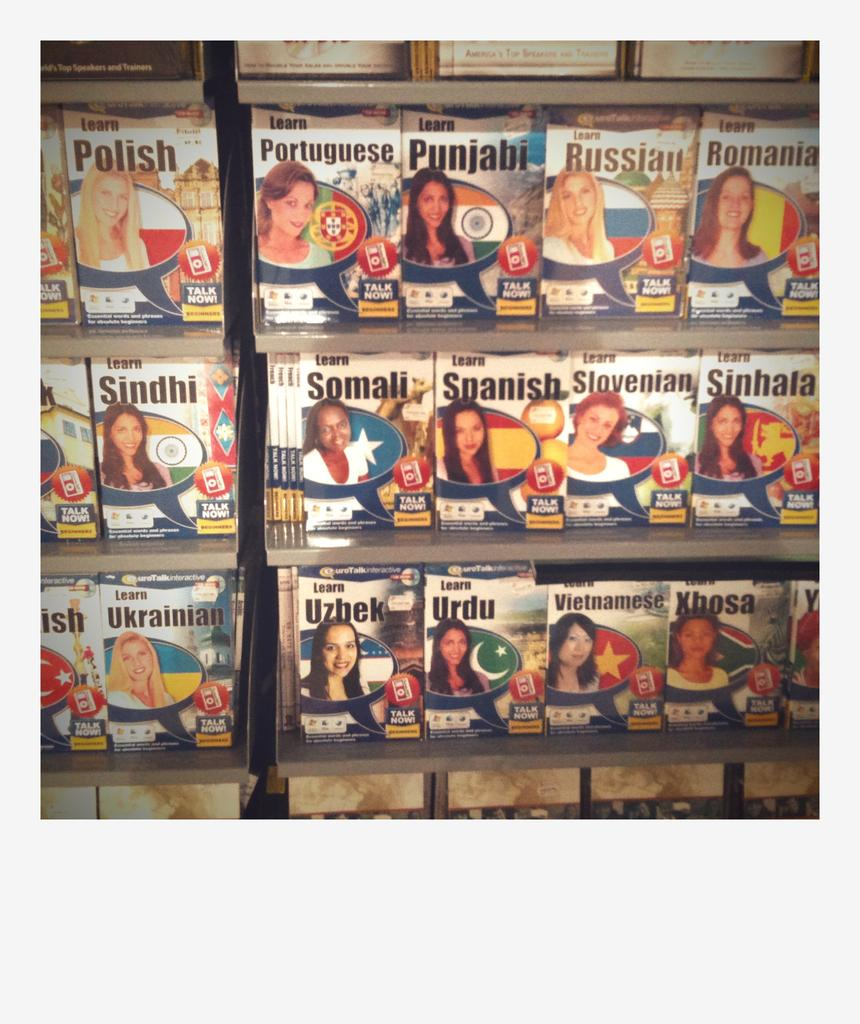<image>
Summarize the visual content of the image. Several books to learn languages are on display, including ones for Uzbek, Urdu, and Vietnamese. 